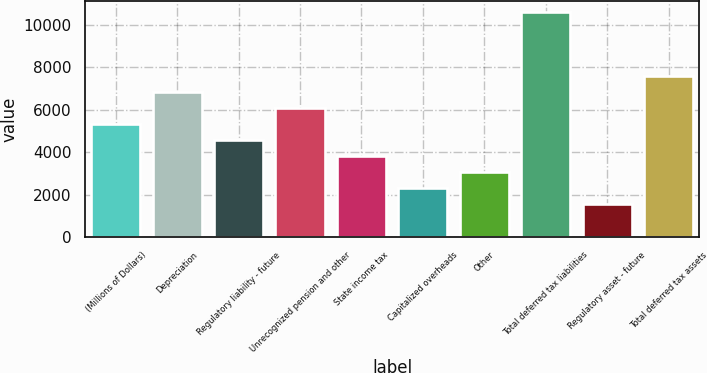Convert chart. <chart><loc_0><loc_0><loc_500><loc_500><bar_chart><fcel>(Millions of Dollars)<fcel>Depreciation<fcel>Regulatory liability - future<fcel>Unrecognized pension and other<fcel>State income tax<fcel>Capitalized overheads<fcel>Other<fcel>Total deferred tax liabilities<fcel>Regulatory asset - future<fcel>Total deferred tax assets<nl><fcel>5338.2<fcel>6843.4<fcel>4585.6<fcel>6090.8<fcel>3833<fcel>2327.8<fcel>3080.4<fcel>10606.4<fcel>1575.2<fcel>7596<nl></chart> 